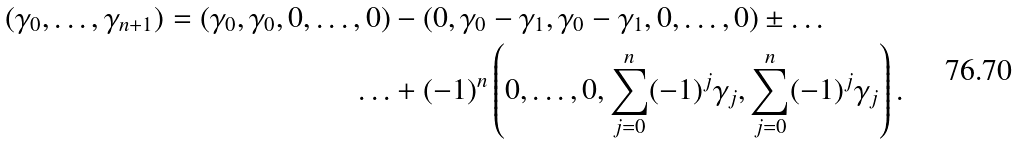<formula> <loc_0><loc_0><loc_500><loc_500>( \gamma _ { 0 } , \dots , \gamma _ { n + 1 } ) = ( \gamma _ { 0 } , \gamma _ { 0 } , 0 , \dots , 0 ) & - ( 0 , \gamma _ { 0 } - \gamma _ { 1 } , \gamma _ { 0 } - \gamma _ { 1 } , 0 , \dots , 0 ) \pm \dots \\ \dots & + ( - 1 ) ^ { n } \left ( 0 , \dots , 0 , \sum _ { j = 0 } ^ { n } ( - 1 ) ^ { j } \gamma _ { j } , \sum _ { j = 0 } ^ { n } ( - 1 ) ^ { j } \gamma _ { j } \right ) .</formula> 